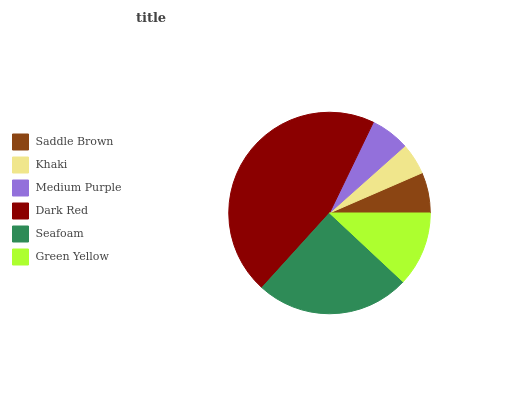Is Khaki the minimum?
Answer yes or no. Yes. Is Dark Red the maximum?
Answer yes or no. Yes. Is Medium Purple the minimum?
Answer yes or no. No. Is Medium Purple the maximum?
Answer yes or no. No. Is Medium Purple greater than Khaki?
Answer yes or no. Yes. Is Khaki less than Medium Purple?
Answer yes or no. Yes. Is Khaki greater than Medium Purple?
Answer yes or no. No. Is Medium Purple less than Khaki?
Answer yes or no. No. Is Green Yellow the high median?
Answer yes or no. Yes. Is Saddle Brown the low median?
Answer yes or no. Yes. Is Saddle Brown the high median?
Answer yes or no. No. Is Medium Purple the low median?
Answer yes or no. No. 